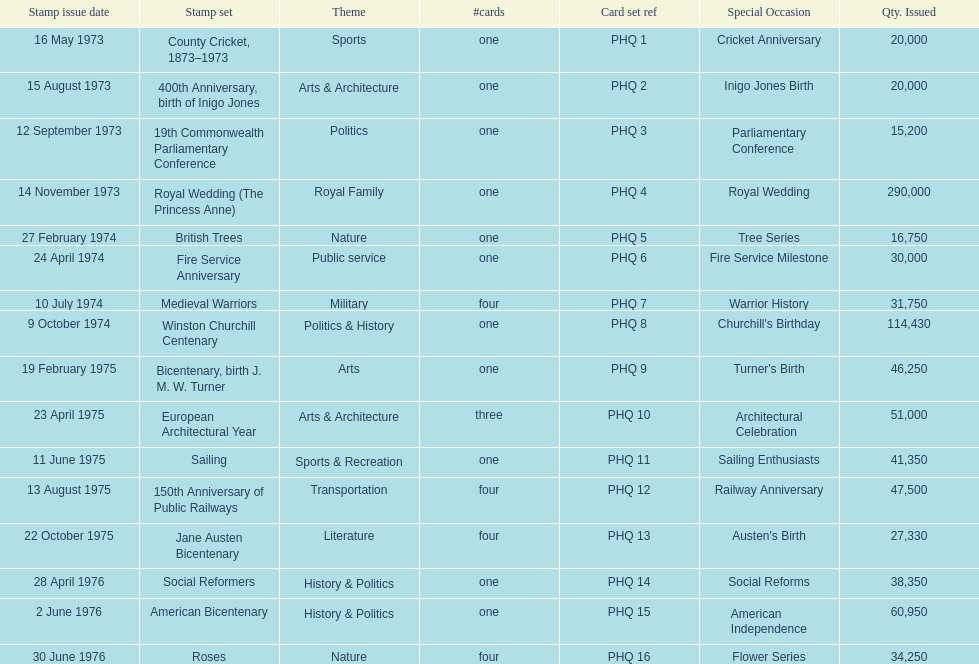Which stamp set had the greatest quantity issued? Royal Wedding (The Princess Anne). 